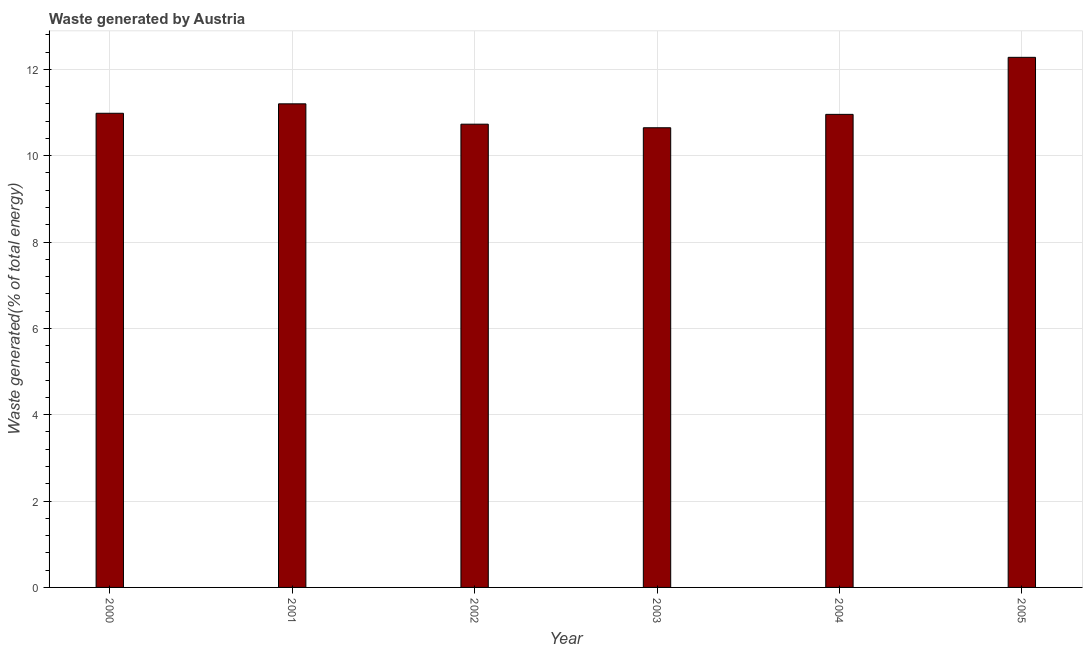Does the graph contain any zero values?
Your answer should be very brief. No. Does the graph contain grids?
Give a very brief answer. Yes. What is the title of the graph?
Ensure brevity in your answer.  Waste generated by Austria. What is the label or title of the Y-axis?
Offer a very short reply. Waste generated(% of total energy). What is the amount of waste generated in 2001?
Ensure brevity in your answer.  11.2. Across all years, what is the maximum amount of waste generated?
Provide a succinct answer. 12.28. Across all years, what is the minimum amount of waste generated?
Offer a very short reply. 10.65. What is the sum of the amount of waste generated?
Provide a short and direct response. 66.79. What is the difference between the amount of waste generated in 2003 and 2004?
Your answer should be compact. -0.31. What is the average amount of waste generated per year?
Provide a short and direct response. 11.13. What is the median amount of waste generated?
Offer a terse response. 10.97. What is the ratio of the amount of waste generated in 2000 to that in 2005?
Your answer should be very brief. 0.89. Is the amount of waste generated in 2004 less than that in 2005?
Keep it short and to the point. Yes. What is the difference between the highest and the second highest amount of waste generated?
Your answer should be compact. 1.08. Is the sum of the amount of waste generated in 2001 and 2002 greater than the maximum amount of waste generated across all years?
Provide a succinct answer. Yes. What is the difference between the highest and the lowest amount of waste generated?
Give a very brief answer. 1.63. In how many years, is the amount of waste generated greater than the average amount of waste generated taken over all years?
Provide a succinct answer. 2. How many bars are there?
Make the answer very short. 6. Are all the bars in the graph horizontal?
Your response must be concise. No. What is the difference between two consecutive major ticks on the Y-axis?
Keep it short and to the point. 2. Are the values on the major ticks of Y-axis written in scientific E-notation?
Offer a very short reply. No. What is the Waste generated(% of total energy) of 2000?
Keep it short and to the point. 10.98. What is the Waste generated(% of total energy) in 2001?
Make the answer very short. 11.2. What is the Waste generated(% of total energy) of 2002?
Offer a very short reply. 10.73. What is the Waste generated(% of total energy) in 2003?
Make the answer very short. 10.65. What is the Waste generated(% of total energy) in 2004?
Keep it short and to the point. 10.96. What is the Waste generated(% of total energy) of 2005?
Ensure brevity in your answer.  12.28. What is the difference between the Waste generated(% of total energy) in 2000 and 2001?
Offer a very short reply. -0.22. What is the difference between the Waste generated(% of total energy) in 2000 and 2002?
Make the answer very short. 0.25. What is the difference between the Waste generated(% of total energy) in 2000 and 2003?
Your answer should be compact. 0.34. What is the difference between the Waste generated(% of total energy) in 2000 and 2004?
Give a very brief answer. 0.03. What is the difference between the Waste generated(% of total energy) in 2000 and 2005?
Provide a succinct answer. -1.3. What is the difference between the Waste generated(% of total energy) in 2001 and 2002?
Your answer should be very brief. 0.47. What is the difference between the Waste generated(% of total energy) in 2001 and 2003?
Ensure brevity in your answer.  0.55. What is the difference between the Waste generated(% of total energy) in 2001 and 2004?
Your answer should be very brief. 0.24. What is the difference between the Waste generated(% of total energy) in 2001 and 2005?
Offer a terse response. -1.08. What is the difference between the Waste generated(% of total energy) in 2002 and 2003?
Ensure brevity in your answer.  0.08. What is the difference between the Waste generated(% of total energy) in 2002 and 2004?
Provide a short and direct response. -0.23. What is the difference between the Waste generated(% of total energy) in 2002 and 2005?
Offer a very short reply. -1.55. What is the difference between the Waste generated(% of total energy) in 2003 and 2004?
Your answer should be very brief. -0.31. What is the difference between the Waste generated(% of total energy) in 2003 and 2005?
Give a very brief answer. -1.63. What is the difference between the Waste generated(% of total energy) in 2004 and 2005?
Offer a very short reply. -1.32. What is the ratio of the Waste generated(% of total energy) in 2000 to that in 2001?
Provide a succinct answer. 0.98. What is the ratio of the Waste generated(% of total energy) in 2000 to that in 2003?
Offer a very short reply. 1.03. What is the ratio of the Waste generated(% of total energy) in 2000 to that in 2004?
Provide a succinct answer. 1. What is the ratio of the Waste generated(% of total energy) in 2000 to that in 2005?
Make the answer very short. 0.89. What is the ratio of the Waste generated(% of total energy) in 2001 to that in 2002?
Ensure brevity in your answer.  1.04. What is the ratio of the Waste generated(% of total energy) in 2001 to that in 2003?
Keep it short and to the point. 1.05. What is the ratio of the Waste generated(% of total energy) in 2001 to that in 2005?
Provide a short and direct response. 0.91. What is the ratio of the Waste generated(% of total energy) in 2002 to that in 2003?
Make the answer very short. 1.01. What is the ratio of the Waste generated(% of total energy) in 2002 to that in 2004?
Offer a very short reply. 0.98. What is the ratio of the Waste generated(% of total energy) in 2002 to that in 2005?
Keep it short and to the point. 0.87. What is the ratio of the Waste generated(% of total energy) in 2003 to that in 2005?
Provide a succinct answer. 0.87. What is the ratio of the Waste generated(% of total energy) in 2004 to that in 2005?
Your answer should be very brief. 0.89. 